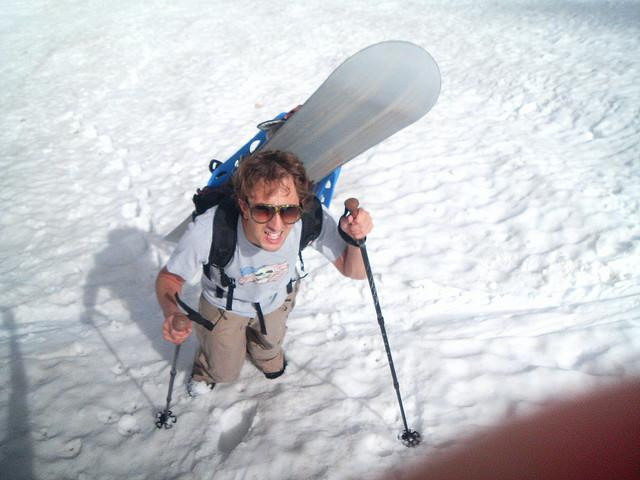What color is the bottom half of the snowboard which is carried up the hill by a man with ski poles?

Choices:
A) blue
B) white
C) red
D) purple white 